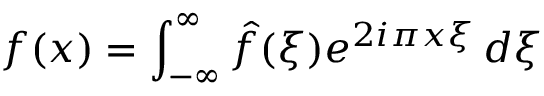Convert formula to latex. <formula><loc_0><loc_0><loc_500><loc_500>f ( x ) = \int _ { - \infty } ^ { \infty } { \hat { f } } ( \xi ) e ^ { 2 i \pi x \xi } \, d \xi</formula> 